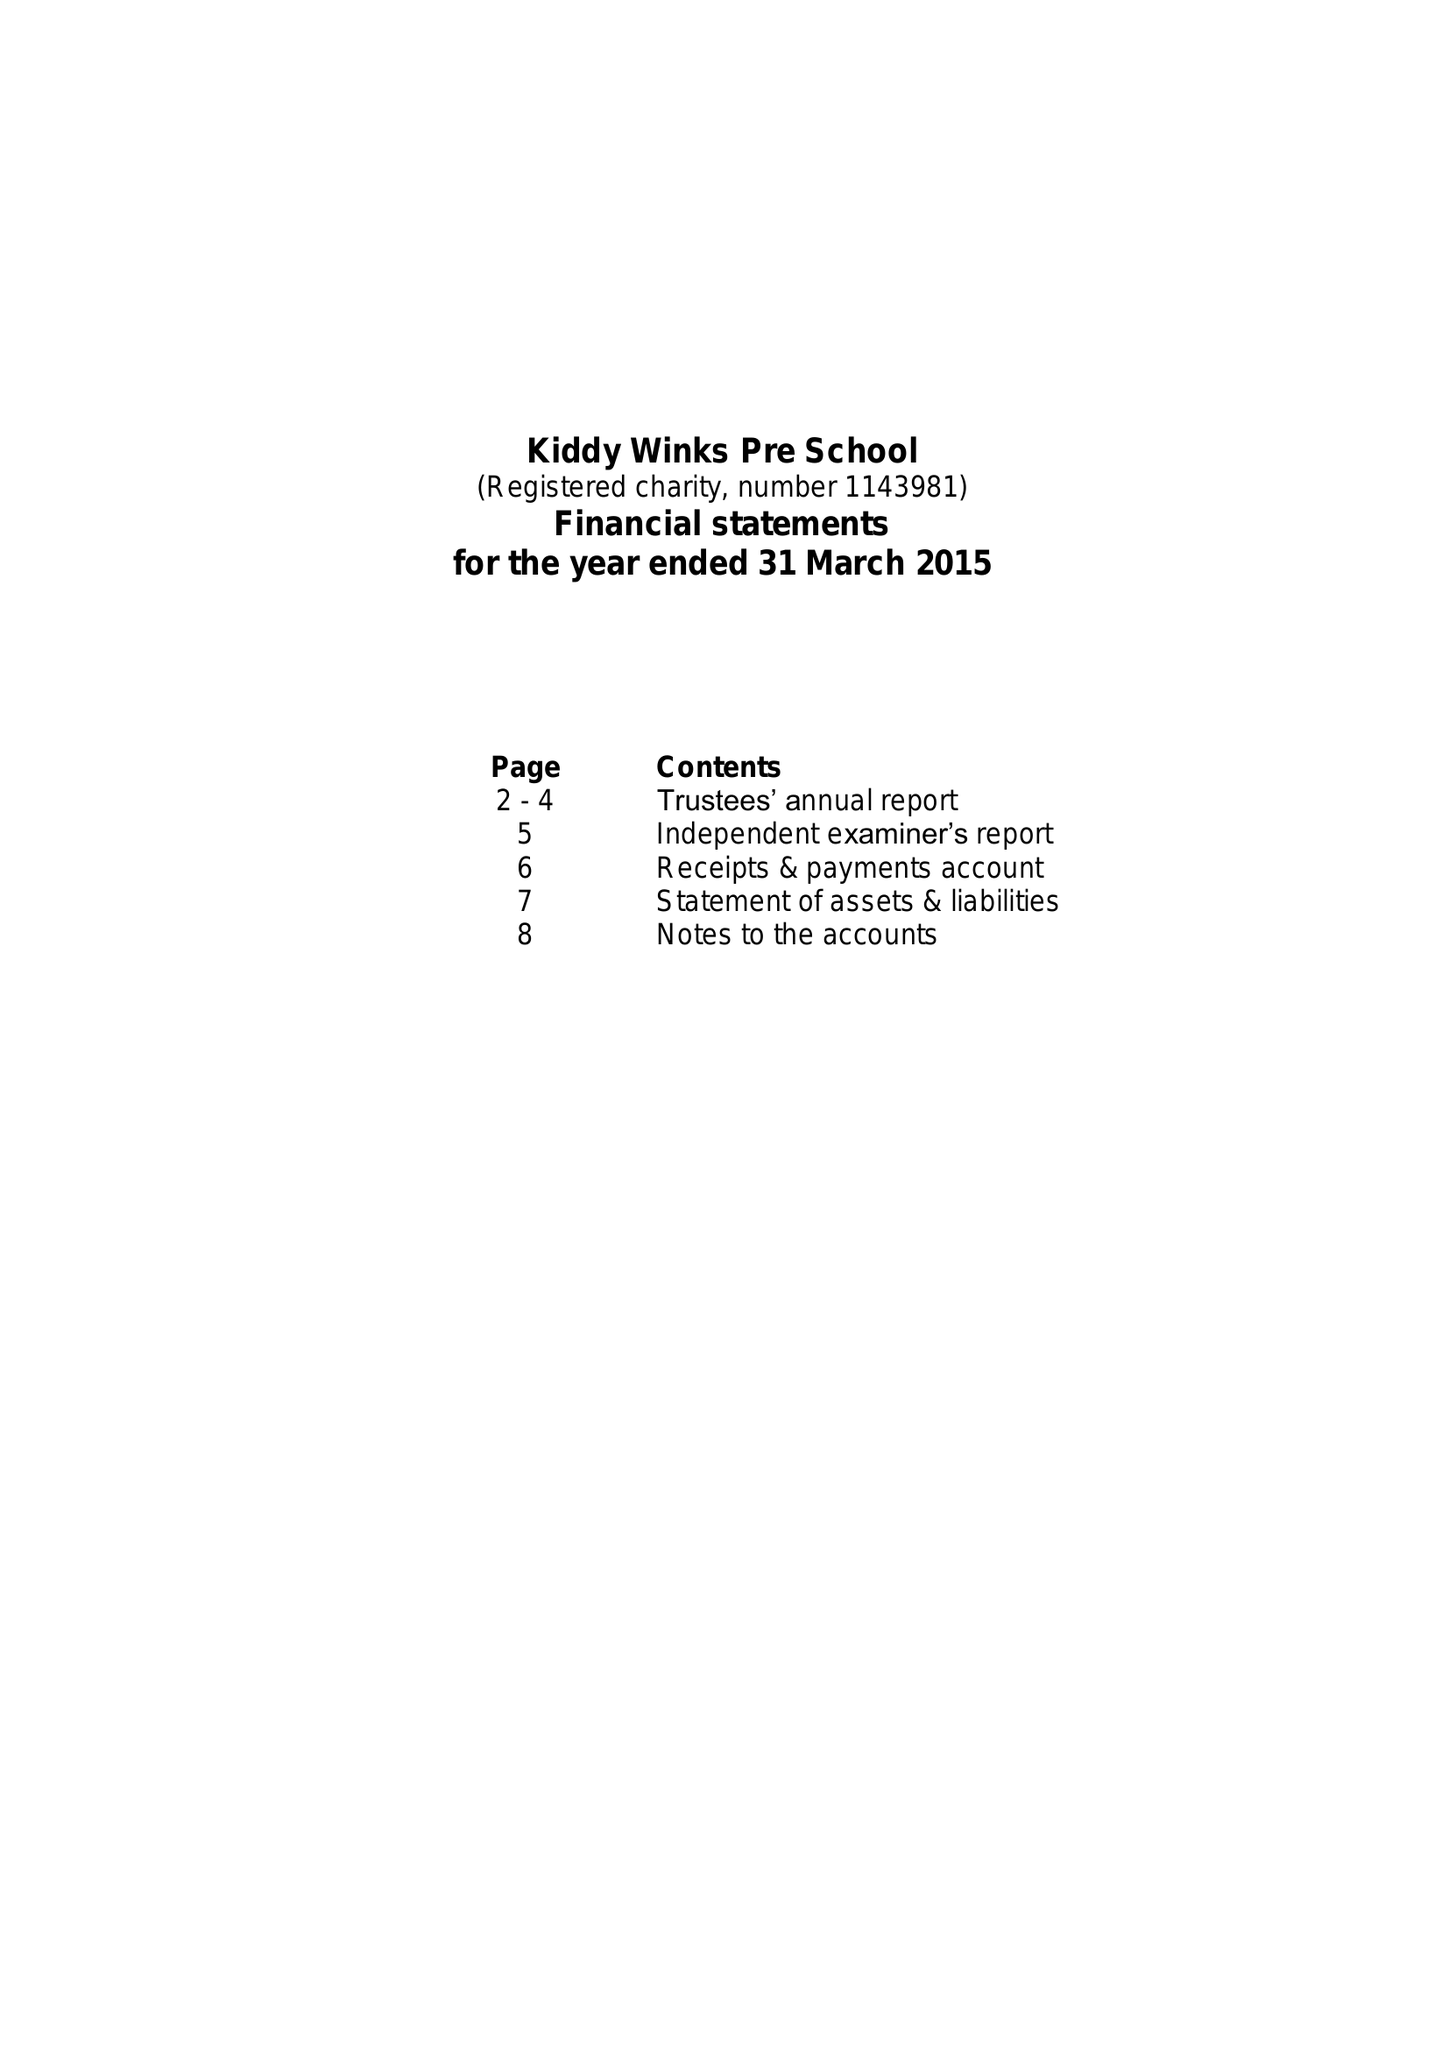What is the value for the address__street_line?
Answer the question using a single word or phrase. 312 SNEINTON DALE 